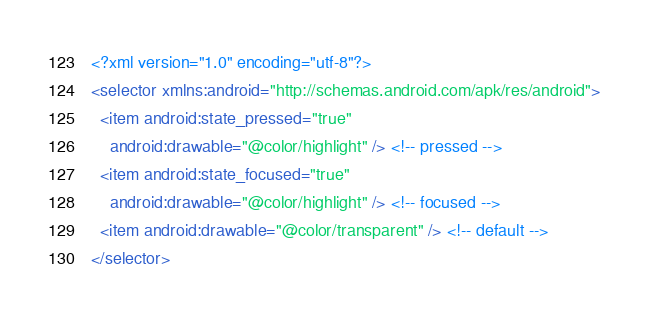Convert code to text. <code><loc_0><loc_0><loc_500><loc_500><_XML_><?xml version="1.0" encoding="utf-8"?>
<selector xmlns:android="http://schemas.android.com/apk/res/android">
  <item android:state_pressed="true"
	android:drawable="@color/highlight" /> <!-- pressed -->
  <item android:state_focused="true"
	android:drawable="@color/highlight" /> <!-- focused -->
  <item android:drawable="@color/transparent" /> <!-- default -->
</selector></code> 